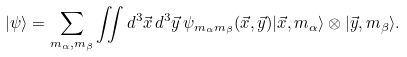<formula> <loc_0><loc_0><loc_500><loc_500>| \psi \rangle = \sum _ { m _ { \alpha } , m _ { \beta } } \iint d ^ { 3 } \vec { x } \, d ^ { 3 } \vec { y } \, \psi _ { m _ { \alpha } m _ { \beta } } ( \vec { x } , \vec { y } ) | \vec { x } , m _ { \alpha } \rangle \otimes | \vec { y } , m _ { \beta } \rangle .</formula> 